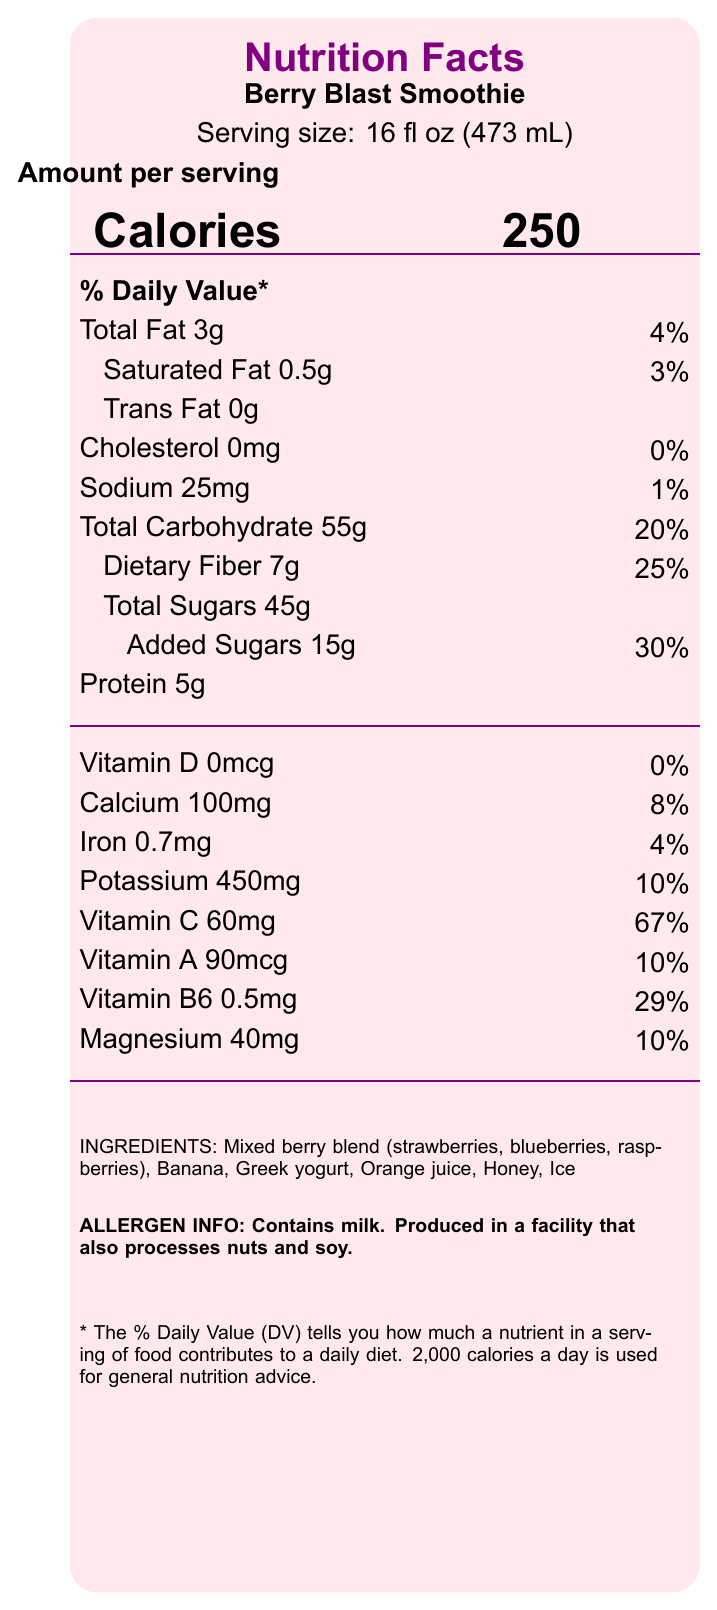what is the serving size of the Berry Blast Smoothie? The serving size is specifically mentioned at the top of the document, just below the product name "Berry Blast Smoothie".
Answer: 16 fl oz (473 mL) how many servings are there per container? According to the document, there is 1 serving per container.
Answer: 1 what is the calorie count per serving? The calorie information is prominently displayed in a large font alongside the word "Calories".
Answer: 250 how much total fat is in one serving? The amount of total fat per serving is listed next to "Total Fat".
Answer: 3g what is the percentage of the daily value for dietary fiber? The percentage of the daily value for dietary fiber is noted as 25%.
Answer: 25% how much calcium is in the smoothie? The amount of calcium is listed specifically under the vitamins and minerals section.
Answer: 100mg What is the highest percentage of daily value in the smoothie? A. Calcium B. Vitamin C C. Vitamin A D. Vitamin B6 Vitamin C has the highest percentage of daily value at 67%.
Answer: B which ingredient is not present in the Berry Blast Smoothie? A. Strawberries B. Raspberries C. Mango D. Banana The ingredients list does not mention mango.
Answer: C is there any cholesterol in the smoothie? The document specifies 0mg cholesterol and a daily value of 0%.
Answer: No summarize the key nutritional information about the Berry Blast Smoothie. This includes all major nutritional components and their values from the provided information.
Answer: The Berry Blast Smoothie contains 250 calories per serving with a serving size of 16 fl oz (473 mL). It provides 3g of total fat (4% DV), 0.5g of saturated fat (3% DV), 0mg of cholesterol (0% DV), 25mg of sodium (1% DV), 55g of total carbohydrates (20% DV), 7g of dietary fiber (25% DV), 45g of total sugars with 15g of added sugars (30% DV), and 5g of protein. It also contains various vitamins and minerals, including Vitamin C at 67% of the daily value. The ingredients include a mixed berry blend, banana, Greek yogurt, orange juice, honey, and ice. what is the daily value percentage of Vitamin D? The document states that there is 0mcg of Vitamin D, corresponding to a daily value of 0%.
Answer: 0% what is the first ingredient listed for the Berry Blast Smoothie? The first ingredient listed is the mixed berry blend.
Answer: Mixed berry blend (strawberries, blueberries, raspberries) how much protein is in one serving of the Berry Blast Smoothie? The amount of protein per serving is listed as 5g.
Answer: 5g does the Berry Blast Smoothie contain added sugars? The document shows that the smoothie contains 15g of added sugars, accounting for 30% daily value.
Answer: Yes is the Berry Blast Smoothie suitable for someone with a nut allergy? While the smoothie does not contain nuts as an ingredient, it is produced in a facility that also processes nuts. This may pose a risk for individuals with nut allergies.
Answer: Cannot be determined what facility conditions are relevant for allergen information? The document mentions allergen information that the product contains milk and is made in a facility that also processes nuts and soy.
Answer: Produced in a facility that also processes nuts and soy. 